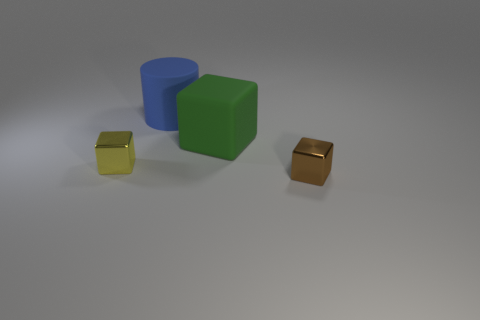What is the color of the tiny metal object that is in front of the small shiny block to the left of the small brown shiny cube?
Keep it short and to the point. Brown. Does the green object have the same shape as the tiny shiny thing that is right of the big matte cylinder?
Ensure brevity in your answer.  Yes. How many other shiny blocks have the same size as the green cube?
Your answer should be compact. 0. What material is the large object that is the same shape as the small brown thing?
Provide a succinct answer. Rubber. There is a metal object that is on the right side of the big blue rubber cylinder; does it have the same color as the tiny object that is left of the small brown thing?
Offer a very short reply. No. There is a small thing to the right of the blue object; what is its shape?
Provide a succinct answer. Cube. What is the color of the big matte cylinder?
Your answer should be compact. Blue. There is another big object that is made of the same material as the blue thing; what is its shape?
Give a very brief answer. Cube. Is the size of the metal thing in front of the yellow thing the same as the green object?
Keep it short and to the point. No. What number of objects are shiny objects that are right of the small yellow block or big matte objects on the right side of the tiny yellow block?
Provide a succinct answer. 3. 